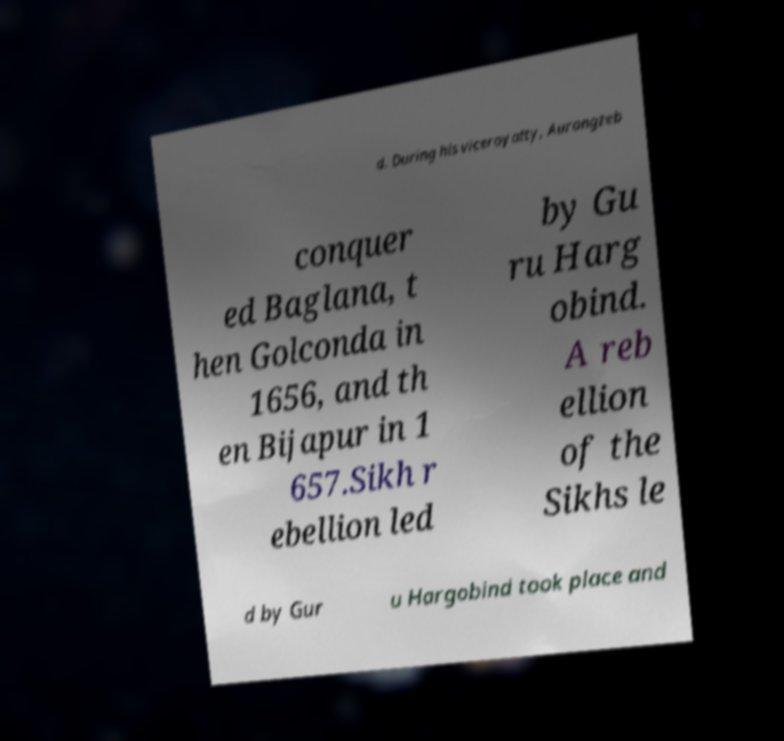Could you assist in decoding the text presented in this image and type it out clearly? d. During his viceroyalty, Aurangzeb conquer ed Baglana, t hen Golconda in 1656, and th en Bijapur in 1 657.Sikh r ebellion led by Gu ru Harg obind. A reb ellion of the Sikhs le d by Gur u Hargobind took place and 